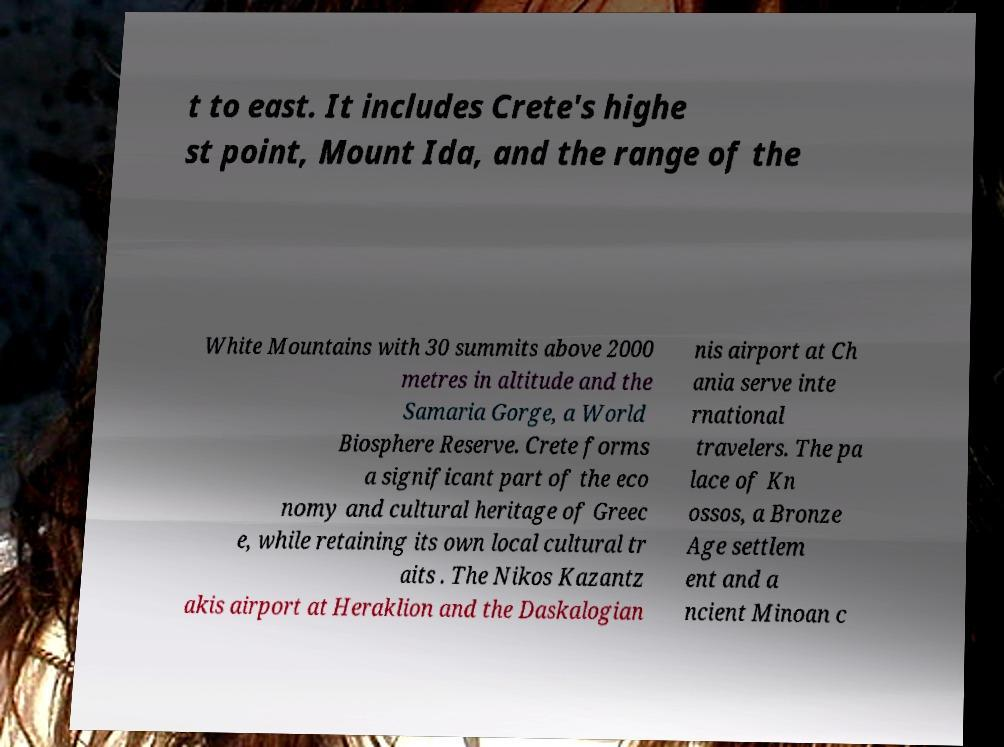Could you extract and type out the text from this image? t to east. It includes Crete's highe st point, Mount Ida, and the range of the White Mountains with 30 summits above 2000 metres in altitude and the Samaria Gorge, a World Biosphere Reserve. Crete forms a significant part of the eco nomy and cultural heritage of Greec e, while retaining its own local cultural tr aits . The Nikos Kazantz akis airport at Heraklion and the Daskalogian nis airport at Ch ania serve inte rnational travelers. The pa lace of Kn ossos, a Bronze Age settlem ent and a ncient Minoan c 